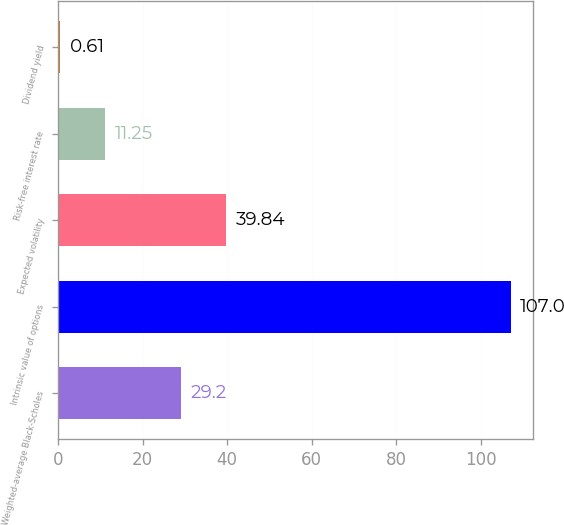Convert chart. <chart><loc_0><loc_0><loc_500><loc_500><bar_chart><fcel>Weighted-average Black-Scholes<fcel>Intrinsic value of options<fcel>Expected volatility<fcel>Risk-free interest rate<fcel>Dividend yield<nl><fcel>29.2<fcel>107<fcel>39.84<fcel>11.25<fcel>0.61<nl></chart> 